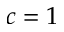<formula> <loc_0><loc_0><loc_500><loc_500>c = 1</formula> 